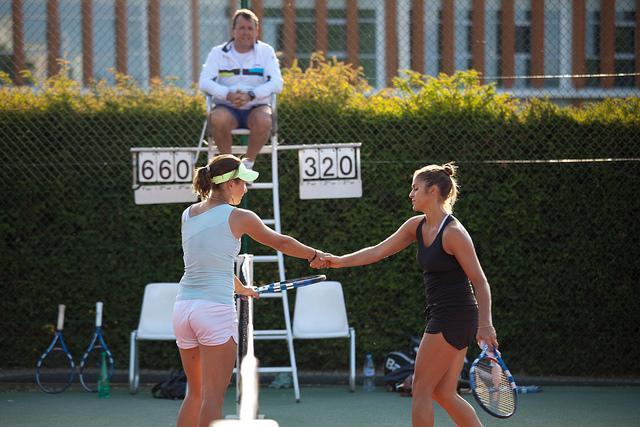How many chairs are there?
Give a very brief answer. 2. How many people are there?
Give a very brief answer. 3. How many pizzas are there?
Give a very brief answer. 0. 